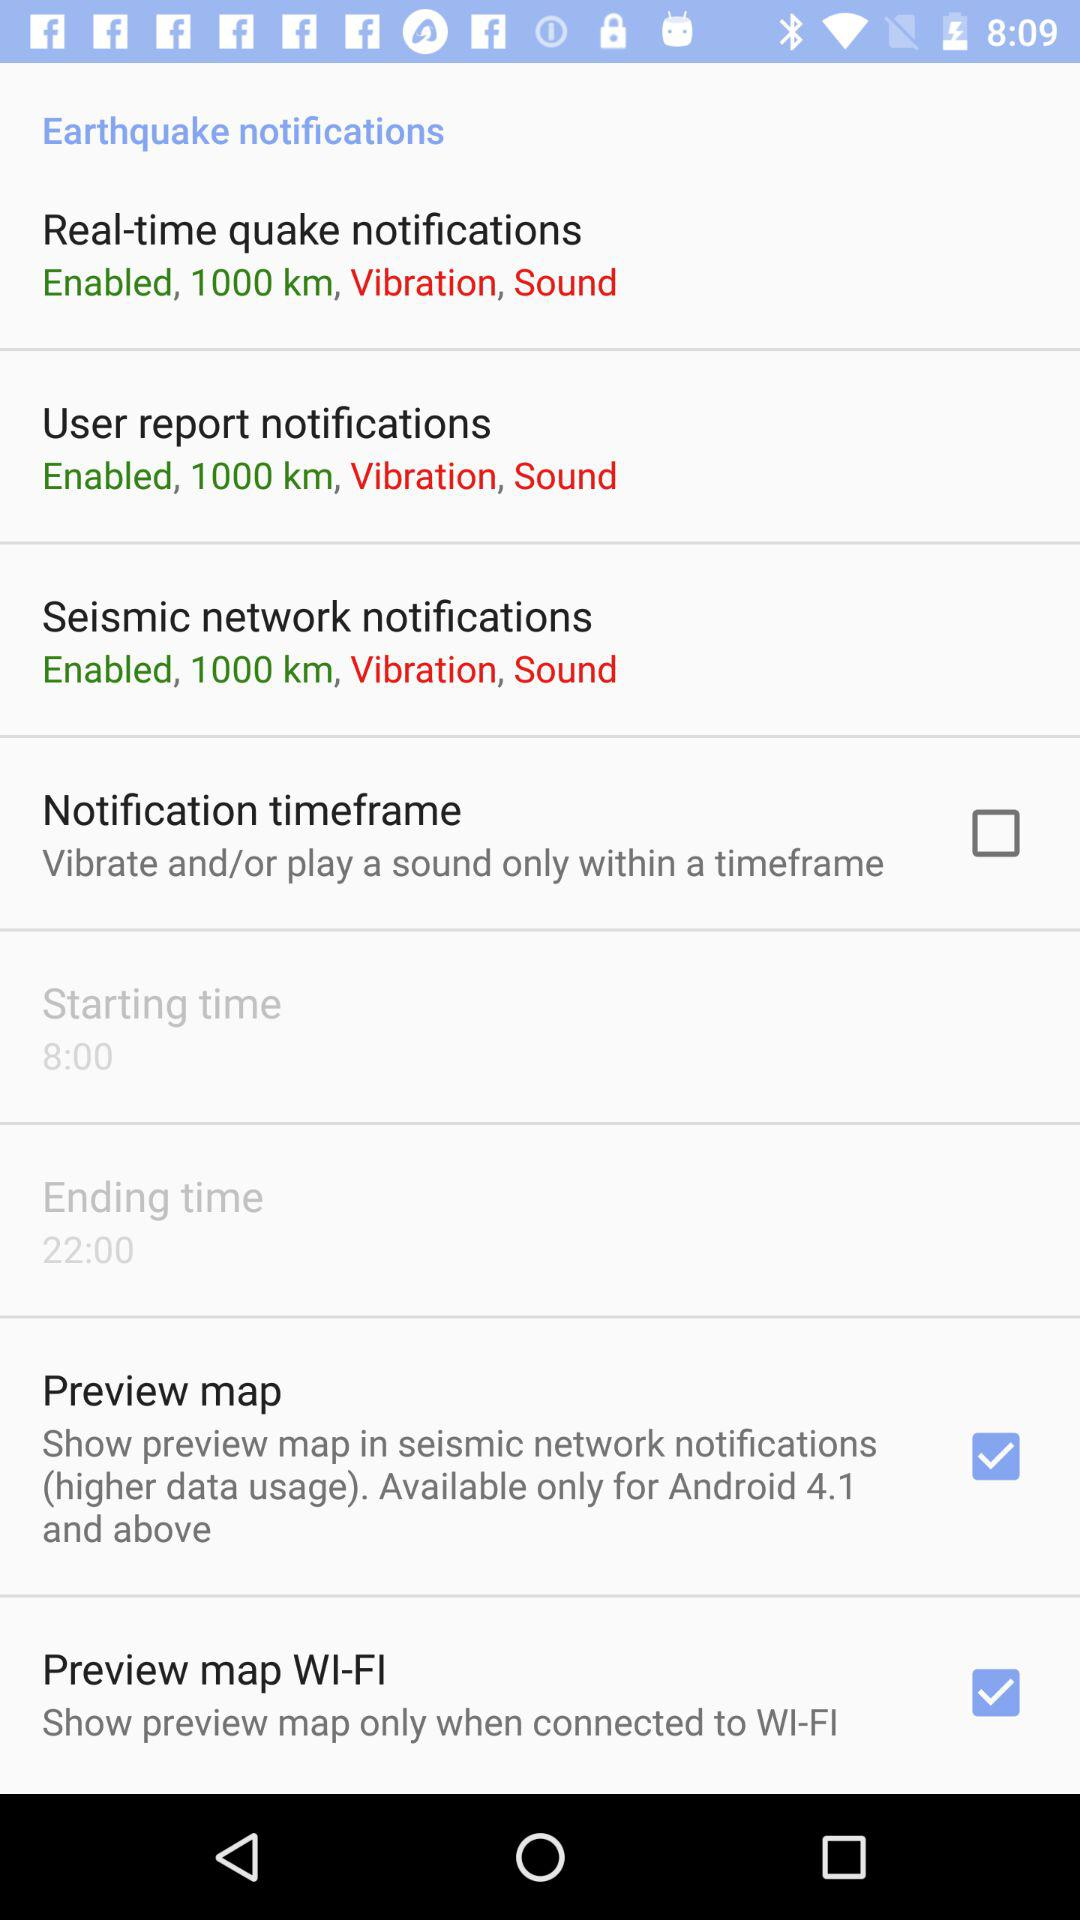What time is shown as the starting time? The starting time is 8:00. 